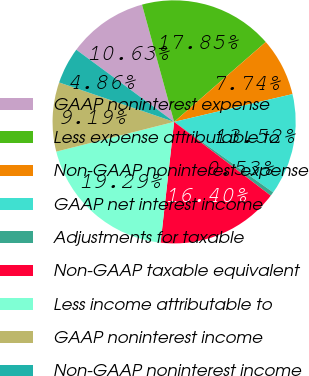Convert chart. <chart><loc_0><loc_0><loc_500><loc_500><pie_chart><fcel>GAAP noninterest expense<fcel>Less expense attributable to<fcel>Non-GAAP noninterest expense<fcel>GAAP net interest income<fcel>Adjustments for taxable<fcel>Non-GAAP taxable equivalent<fcel>Less income attributable to<fcel>GAAP noninterest income<fcel>Non-GAAP noninterest income<nl><fcel>10.63%<fcel>17.85%<fcel>7.74%<fcel>13.52%<fcel>0.53%<fcel>16.4%<fcel>19.29%<fcel>9.19%<fcel>4.86%<nl></chart> 